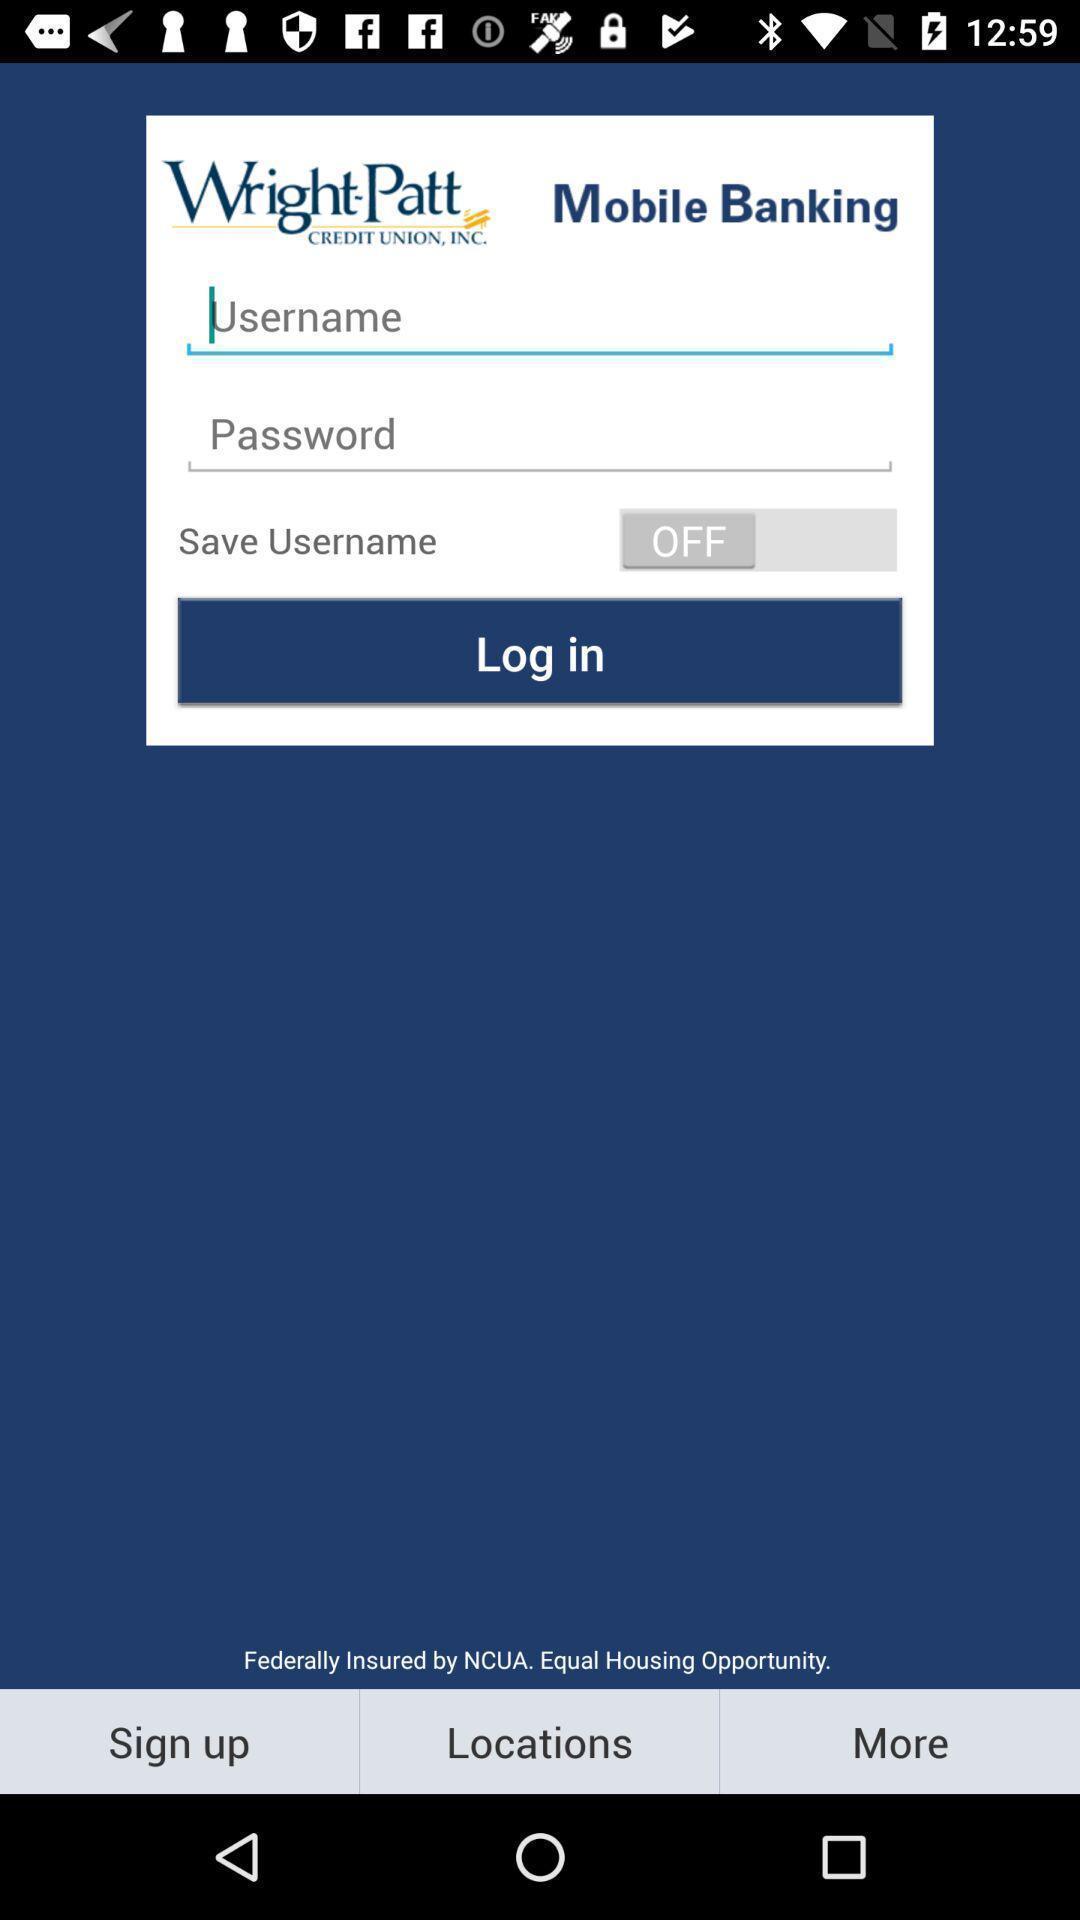What is the overall content of this screenshot? Screen shows to login a mobile banking app. 